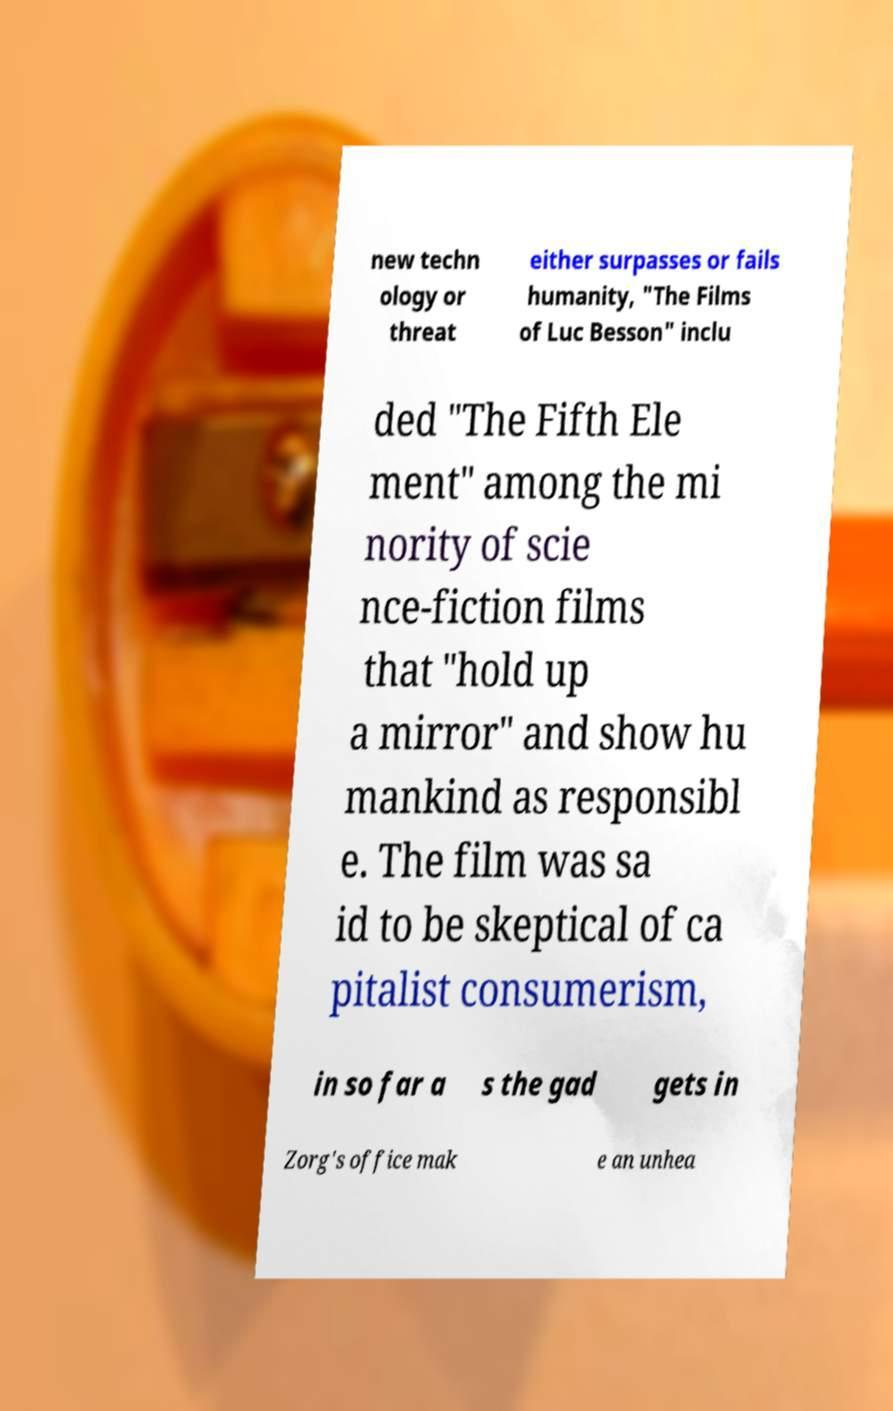What messages or text are displayed in this image? I need them in a readable, typed format. new techn ology or threat either surpasses or fails humanity, "The Films of Luc Besson" inclu ded "The Fifth Ele ment" among the mi nority of scie nce-fiction films that "hold up a mirror" and show hu mankind as responsibl e. The film was sa id to be skeptical of ca pitalist consumerism, in so far a s the gad gets in Zorg's office mak e an unhea 